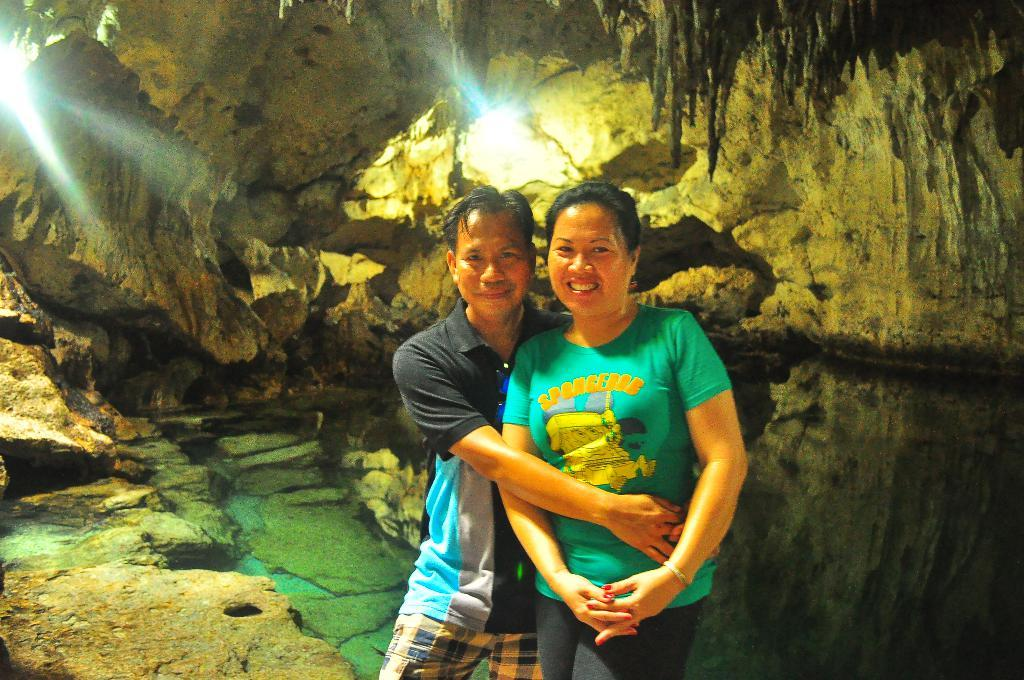Where might the image have been taken? The image might have been taken inside a cave. How many people are present in the image? There are two people, a man and a woman, present in the image. What can be seen in the background of the image? There are lights and rocks visible in the background of the image. Can you tell me where the faucet is located in the image? There is no faucet present in the image. How many stars can be seen in the image? There are no stars visible in the image, as it appears to be taken inside a cave. 